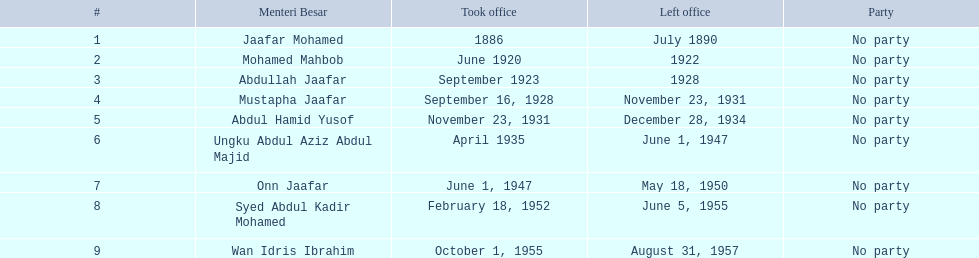Who was in office previous to abdullah jaafar? Mohamed Mahbob. 